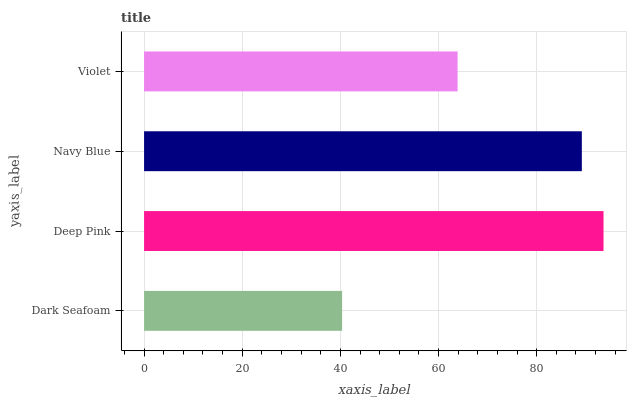Is Dark Seafoam the minimum?
Answer yes or no. Yes. Is Deep Pink the maximum?
Answer yes or no. Yes. Is Navy Blue the minimum?
Answer yes or no. No. Is Navy Blue the maximum?
Answer yes or no. No. Is Deep Pink greater than Navy Blue?
Answer yes or no. Yes. Is Navy Blue less than Deep Pink?
Answer yes or no. Yes. Is Navy Blue greater than Deep Pink?
Answer yes or no. No. Is Deep Pink less than Navy Blue?
Answer yes or no. No. Is Navy Blue the high median?
Answer yes or no. Yes. Is Violet the low median?
Answer yes or no. Yes. Is Deep Pink the high median?
Answer yes or no. No. Is Navy Blue the low median?
Answer yes or no. No. 